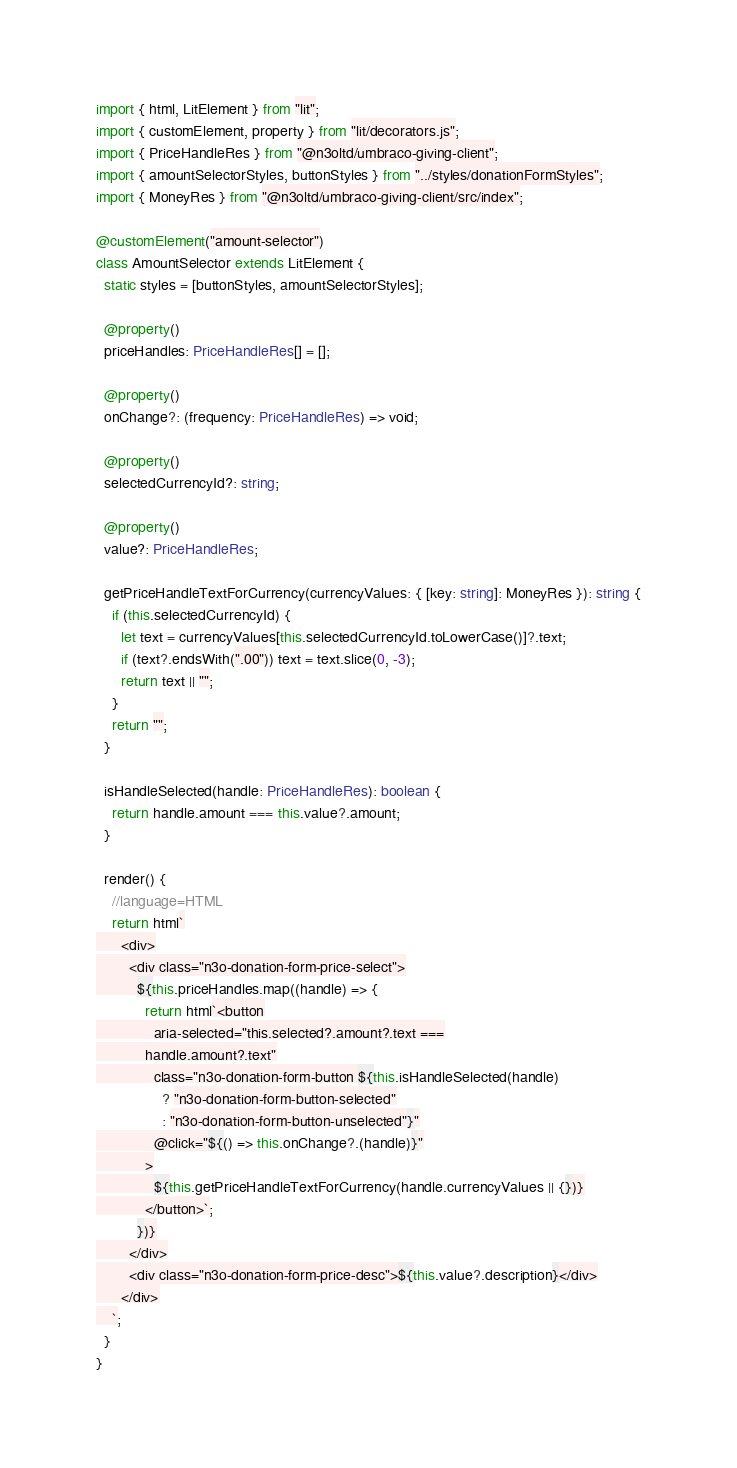<code> <loc_0><loc_0><loc_500><loc_500><_TypeScript_>import { html, LitElement } from "lit";
import { customElement, property } from "lit/decorators.js";
import { PriceHandleRes } from "@n3oltd/umbraco-giving-client";
import { amountSelectorStyles, buttonStyles } from "../styles/donationFormStyles";
import { MoneyRes } from "@n3oltd/umbraco-giving-client/src/index";

@customElement("amount-selector")
class AmountSelector extends LitElement {
  static styles = [buttonStyles, amountSelectorStyles];

  @property()
  priceHandles: PriceHandleRes[] = [];

  @property()
  onChange?: (frequency: PriceHandleRes) => void;

  @property()
  selectedCurrencyId?: string;

  @property()
  value?: PriceHandleRes;

  getPriceHandleTextForCurrency(currencyValues: { [key: string]: MoneyRes }): string {
    if (this.selectedCurrencyId) {
      let text = currencyValues[this.selectedCurrencyId.toLowerCase()]?.text;
      if (text?.endsWith(".00")) text = text.slice(0, -3);
      return text || "";
    }
    return "";
  }

  isHandleSelected(handle: PriceHandleRes): boolean {
    return handle.amount === this.value?.amount;
  }

  render() {
    //language=HTML
    return html`
      <div>
        <div class="n3o-donation-form-price-select">
          ${this.priceHandles.map((handle) => {
            return html`<button
              aria-selected="this.selected?.amount?.text ===
            handle.amount?.text"
              class="n3o-donation-form-button ${this.isHandleSelected(handle)
                ? "n3o-donation-form-button-selected"
                : "n3o-donation-form-button-unselected"}"
              @click="${() => this.onChange?.(handle)}"
            >
              ${this.getPriceHandleTextForCurrency(handle.currencyValues || {})}
            </button>`;
          })}
        </div>
        <div class="n3o-donation-form-price-desc">${this.value?.description}</div>
      </div>
    `;
  }
}
</code> 